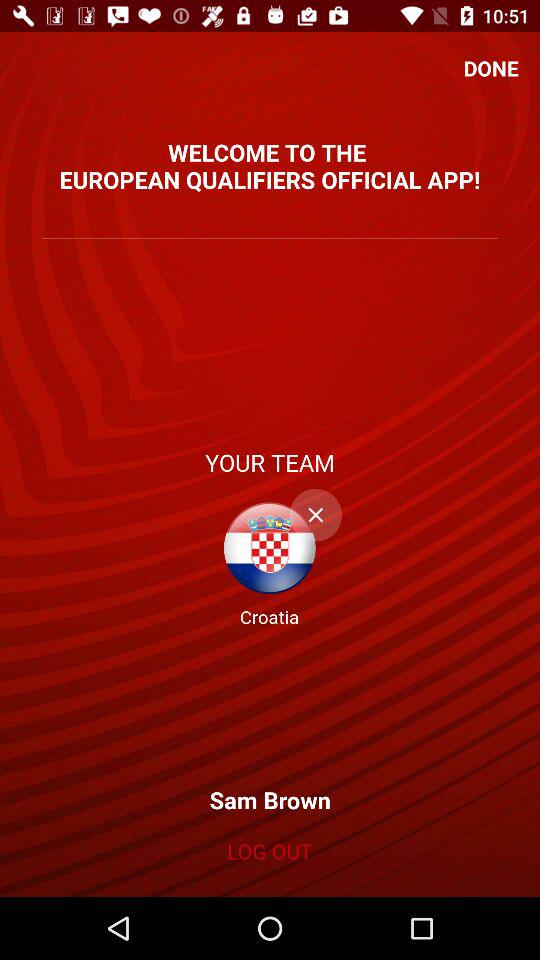What's the user's team name? The user's team name is "Croatia". 